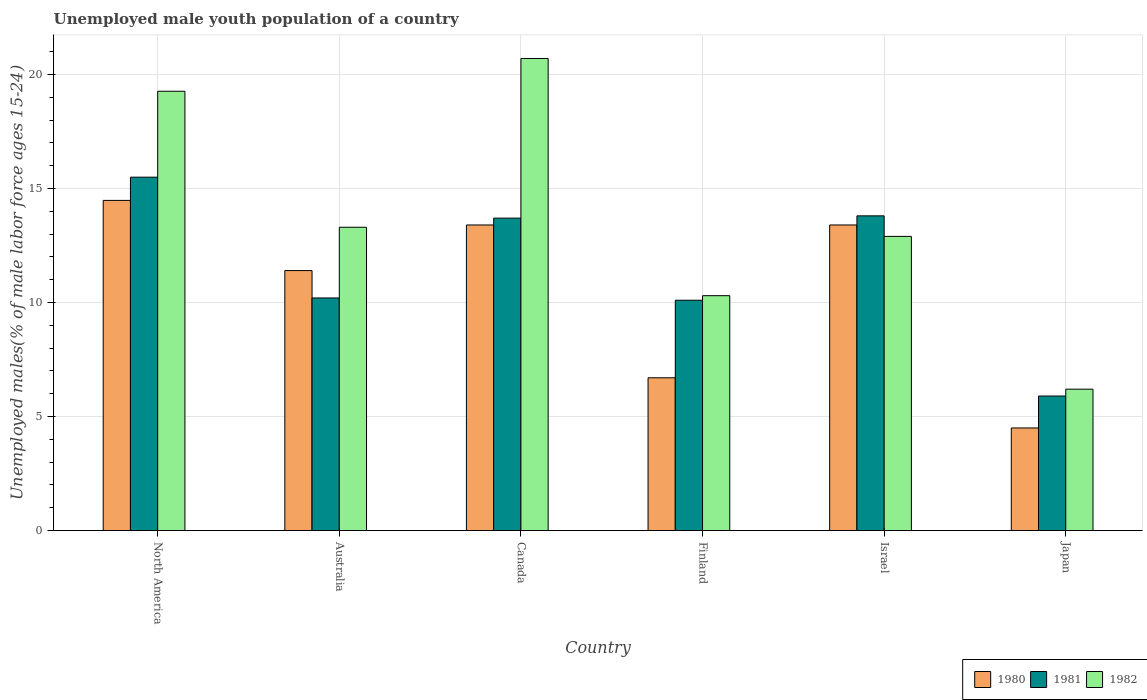How many groups of bars are there?
Offer a terse response. 6. Are the number of bars per tick equal to the number of legend labels?
Ensure brevity in your answer.  Yes. Are the number of bars on each tick of the X-axis equal?
Ensure brevity in your answer.  Yes. How many bars are there on the 1st tick from the left?
Your answer should be very brief. 3. How many bars are there on the 5th tick from the right?
Provide a succinct answer. 3. What is the label of the 4th group of bars from the left?
Give a very brief answer. Finland. In how many cases, is the number of bars for a given country not equal to the number of legend labels?
Provide a short and direct response. 0. What is the percentage of unemployed male youth population in 1982 in Israel?
Provide a short and direct response. 12.9. Across all countries, what is the maximum percentage of unemployed male youth population in 1982?
Ensure brevity in your answer.  20.7. Across all countries, what is the minimum percentage of unemployed male youth population in 1982?
Provide a short and direct response. 6.2. In which country was the percentage of unemployed male youth population in 1980 maximum?
Give a very brief answer. North America. What is the total percentage of unemployed male youth population in 1980 in the graph?
Provide a succinct answer. 63.88. What is the difference between the percentage of unemployed male youth population in 1982 in Finland and that in Israel?
Ensure brevity in your answer.  -2.6. What is the difference between the percentage of unemployed male youth population in 1981 in Israel and the percentage of unemployed male youth population in 1980 in Canada?
Provide a short and direct response. 0.4. What is the average percentage of unemployed male youth population in 1982 per country?
Keep it short and to the point. 13.78. What is the difference between the percentage of unemployed male youth population of/in 1980 and percentage of unemployed male youth population of/in 1981 in Australia?
Make the answer very short. 1.2. In how many countries, is the percentage of unemployed male youth population in 1980 greater than 1 %?
Offer a very short reply. 6. What is the ratio of the percentage of unemployed male youth population in 1980 in Australia to that in Finland?
Provide a succinct answer. 1.7. What is the difference between the highest and the second highest percentage of unemployed male youth population in 1981?
Your answer should be compact. -0.1. What is the difference between the highest and the lowest percentage of unemployed male youth population in 1982?
Ensure brevity in your answer.  14.5. Is the sum of the percentage of unemployed male youth population in 1982 in Australia and North America greater than the maximum percentage of unemployed male youth population in 1980 across all countries?
Your answer should be compact. Yes. What does the 3rd bar from the left in Finland represents?
Provide a succinct answer. 1982. What does the 1st bar from the right in North America represents?
Provide a succinct answer. 1982. Is it the case that in every country, the sum of the percentage of unemployed male youth population in 1980 and percentage of unemployed male youth population in 1981 is greater than the percentage of unemployed male youth population in 1982?
Your answer should be compact. Yes. Are all the bars in the graph horizontal?
Give a very brief answer. No. Does the graph contain grids?
Your answer should be very brief. Yes. Where does the legend appear in the graph?
Provide a succinct answer. Bottom right. How many legend labels are there?
Make the answer very short. 3. What is the title of the graph?
Make the answer very short. Unemployed male youth population of a country. Does "1985" appear as one of the legend labels in the graph?
Ensure brevity in your answer.  No. What is the label or title of the X-axis?
Offer a very short reply. Country. What is the label or title of the Y-axis?
Provide a short and direct response. Unemployed males(% of male labor force ages 15-24). What is the Unemployed males(% of male labor force ages 15-24) in 1980 in North America?
Keep it short and to the point. 14.48. What is the Unemployed males(% of male labor force ages 15-24) in 1981 in North America?
Provide a short and direct response. 15.5. What is the Unemployed males(% of male labor force ages 15-24) in 1982 in North America?
Keep it short and to the point. 19.26. What is the Unemployed males(% of male labor force ages 15-24) of 1980 in Australia?
Give a very brief answer. 11.4. What is the Unemployed males(% of male labor force ages 15-24) of 1981 in Australia?
Make the answer very short. 10.2. What is the Unemployed males(% of male labor force ages 15-24) of 1982 in Australia?
Offer a very short reply. 13.3. What is the Unemployed males(% of male labor force ages 15-24) of 1980 in Canada?
Give a very brief answer. 13.4. What is the Unemployed males(% of male labor force ages 15-24) in 1981 in Canada?
Provide a succinct answer. 13.7. What is the Unemployed males(% of male labor force ages 15-24) in 1982 in Canada?
Your answer should be very brief. 20.7. What is the Unemployed males(% of male labor force ages 15-24) in 1980 in Finland?
Your answer should be very brief. 6.7. What is the Unemployed males(% of male labor force ages 15-24) in 1981 in Finland?
Give a very brief answer. 10.1. What is the Unemployed males(% of male labor force ages 15-24) of 1982 in Finland?
Your answer should be very brief. 10.3. What is the Unemployed males(% of male labor force ages 15-24) in 1980 in Israel?
Provide a succinct answer. 13.4. What is the Unemployed males(% of male labor force ages 15-24) in 1981 in Israel?
Ensure brevity in your answer.  13.8. What is the Unemployed males(% of male labor force ages 15-24) in 1982 in Israel?
Your response must be concise. 12.9. What is the Unemployed males(% of male labor force ages 15-24) in 1980 in Japan?
Provide a short and direct response. 4.5. What is the Unemployed males(% of male labor force ages 15-24) in 1981 in Japan?
Ensure brevity in your answer.  5.9. What is the Unemployed males(% of male labor force ages 15-24) in 1982 in Japan?
Keep it short and to the point. 6.2. Across all countries, what is the maximum Unemployed males(% of male labor force ages 15-24) of 1980?
Offer a very short reply. 14.48. Across all countries, what is the maximum Unemployed males(% of male labor force ages 15-24) of 1981?
Make the answer very short. 15.5. Across all countries, what is the maximum Unemployed males(% of male labor force ages 15-24) of 1982?
Offer a very short reply. 20.7. Across all countries, what is the minimum Unemployed males(% of male labor force ages 15-24) of 1980?
Your answer should be very brief. 4.5. Across all countries, what is the minimum Unemployed males(% of male labor force ages 15-24) of 1981?
Give a very brief answer. 5.9. Across all countries, what is the minimum Unemployed males(% of male labor force ages 15-24) of 1982?
Give a very brief answer. 6.2. What is the total Unemployed males(% of male labor force ages 15-24) of 1980 in the graph?
Your response must be concise. 63.88. What is the total Unemployed males(% of male labor force ages 15-24) in 1981 in the graph?
Your response must be concise. 69.2. What is the total Unemployed males(% of male labor force ages 15-24) of 1982 in the graph?
Provide a short and direct response. 82.66. What is the difference between the Unemployed males(% of male labor force ages 15-24) in 1980 in North America and that in Australia?
Ensure brevity in your answer.  3.08. What is the difference between the Unemployed males(% of male labor force ages 15-24) of 1981 in North America and that in Australia?
Provide a succinct answer. 5.3. What is the difference between the Unemployed males(% of male labor force ages 15-24) in 1982 in North America and that in Australia?
Provide a succinct answer. 5.96. What is the difference between the Unemployed males(% of male labor force ages 15-24) in 1980 in North America and that in Canada?
Your response must be concise. 1.08. What is the difference between the Unemployed males(% of male labor force ages 15-24) in 1981 in North America and that in Canada?
Provide a succinct answer. 1.8. What is the difference between the Unemployed males(% of male labor force ages 15-24) in 1982 in North America and that in Canada?
Your response must be concise. -1.44. What is the difference between the Unemployed males(% of male labor force ages 15-24) in 1980 in North America and that in Finland?
Your answer should be compact. 7.78. What is the difference between the Unemployed males(% of male labor force ages 15-24) of 1981 in North America and that in Finland?
Ensure brevity in your answer.  5.4. What is the difference between the Unemployed males(% of male labor force ages 15-24) in 1982 in North America and that in Finland?
Your answer should be compact. 8.96. What is the difference between the Unemployed males(% of male labor force ages 15-24) in 1980 in North America and that in Israel?
Provide a short and direct response. 1.08. What is the difference between the Unemployed males(% of male labor force ages 15-24) of 1981 in North America and that in Israel?
Provide a succinct answer. 1.7. What is the difference between the Unemployed males(% of male labor force ages 15-24) of 1982 in North America and that in Israel?
Keep it short and to the point. 6.36. What is the difference between the Unemployed males(% of male labor force ages 15-24) of 1980 in North America and that in Japan?
Ensure brevity in your answer.  9.98. What is the difference between the Unemployed males(% of male labor force ages 15-24) in 1981 in North America and that in Japan?
Provide a short and direct response. 9.6. What is the difference between the Unemployed males(% of male labor force ages 15-24) of 1982 in North America and that in Japan?
Give a very brief answer. 13.06. What is the difference between the Unemployed males(% of male labor force ages 15-24) of 1980 in Australia and that in Canada?
Provide a succinct answer. -2. What is the difference between the Unemployed males(% of male labor force ages 15-24) in 1980 in Australia and that in Finland?
Offer a very short reply. 4.7. What is the difference between the Unemployed males(% of male labor force ages 15-24) in 1981 in Australia and that in Finland?
Provide a short and direct response. 0.1. What is the difference between the Unemployed males(% of male labor force ages 15-24) of 1982 in Australia and that in Finland?
Ensure brevity in your answer.  3. What is the difference between the Unemployed males(% of male labor force ages 15-24) in 1980 in Australia and that in Israel?
Offer a very short reply. -2. What is the difference between the Unemployed males(% of male labor force ages 15-24) of 1980 in Australia and that in Japan?
Provide a short and direct response. 6.9. What is the difference between the Unemployed males(% of male labor force ages 15-24) in 1980 in Canada and that in Finland?
Your answer should be compact. 6.7. What is the difference between the Unemployed males(% of male labor force ages 15-24) in 1982 in Canada and that in Finland?
Offer a very short reply. 10.4. What is the difference between the Unemployed males(% of male labor force ages 15-24) of 1980 in Canada and that in Israel?
Offer a very short reply. 0. What is the difference between the Unemployed males(% of male labor force ages 15-24) in 1981 in Canada and that in Israel?
Provide a short and direct response. -0.1. What is the difference between the Unemployed males(% of male labor force ages 15-24) in 1982 in Canada and that in Israel?
Provide a succinct answer. 7.8. What is the difference between the Unemployed males(% of male labor force ages 15-24) in 1981 in Canada and that in Japan?
Offer a terse response. 7.8. What is the difference between the Unemployed males(% of male labor force ages 15-24) in 1980 in Finland and that in Israel?
Ensure brevity in your answer.  -6.7. What is the difference between the Unemployed males(% of male labor force ages 15-24) of 1982 in Finland and that in Israel?
Offer a very short reply. -2.6. What is the difference between the Unemployed males(% of male labor force ages 15-24) of 1980 in Finland and that in Japan?
Your answer should be very brief. 2.2. What is the difference between the Unemployed males(% of male labor force ages 15-24) of 1982 in Finland and that in Japan?
Offer a terse response. 4.1. What is the difference between the Unemployed males(% of male labor force ages 15-24) in 1980 in Israel and that in Japan?
Give a very brief answer. 8.9. What is the difference between the Unemployed males(% of male labor force ages 15-24) in 1982 in Israel and that in Japan?
Your answer should be compact. 6.7. What is the difference between the Unemployed males(% of male labor force ages 15-24) in 1980 in North America and the Unemployed males(% of male labor force ages 15-24) in 1981 in Australia?
Offer a terse response. 4.28. What is the difference between the Unemployed males(% of male labor force ages 15-24) of 1980 in North America and the Unemployed males(% of male labor force ages 15-24) of 1982 in Australia?
Offer a terse response. 1.18. What is the difference between the Unemployed males(% of male labor force ages 15-24) in 1981 in North America and the Unemployed males(% of male labor force ages 15-24) in 1982 in Australia?
Make the answer very short. 2.2. What is the difference between the Unemployed males(% of male labor force ages 15-24) in 1980 in North America and the Unemployed males(% of male labor force ages 15-24) in 1981 in Canada?
Provide a short and direct response. 0.78. What is the difference between the Unemployed males(% of male labor force ages 15-24) in 1980 in North America and the Unemployed males(% of male labor force ages 15-24) in 1982 in Canada?
Give a very brief answer. -6.22. What is the difference between the Unemployed males(% of male labor force ages 15-24) of 1981 in North America and the Unemployed males(% of male labor force ages 15-24) of 1982 in Canada?
Offer a very short reply. -5.2. What is the difference between the Unemployed males(% of male labor force ages 15-24) of 1980 in North America and the Unemployed males(% of male labor force ages 15-24) of 1981 in Finland?
Provide a short and direct response. 4.38. What is the difference between the Unemployed males(% of male labor force ages 15-24) in 1980 in North America and the Unemployed males(% of male labor force ages 15-24) in 1982 in Finland?
Provide a succinct answer. 4.18. What is the difference between the Unemployed males(% of male labor force ages 15-24) in 1981 in North America and the Unemployed males(% of male labor force ages 15-24) in 1982 in Finland?
Keep it short and to the point. 5.2. What is the difference between the Unemployed males(% of male labor force ages 15-24) of 1980 in North America and the Unemployed males(% of male labor force ages 15-24) of 1981 in Israel?
Keep it short and to the point. 0.68. What is the difference between the Unemployed males(% of male labor force ages 15-24) of 1980 in North America and the Unemployed males(% of male labor force ages 15-24) of 1982 in Israel?
Your answer should be very brief. 1.58. What is the difference between the Unemployed males(% of male labor force ages 15-24) of 1981 in North America and the Unemployed males(% of male labor force ages 15-24) of 1982 in Israel?
Ensure brevity in your answer.  2.6. What is the difference between the Unemployed males(% of male labor force ages 15-24) of 1980 in North America and the Unemployed males(% of male labor force ages 15-24) of 1981 in Japan?
Keep it short and to the point. 8.58. What is the difference between the Unemployed males(% of male labor force ages 15-24) of 1980 in North America and the Unemployed males(% of male labor force ages 15-24) of 1982 in Japan?
Ensure brevity in your answer.  8.28. What is the difference between the Unemployed males(% of male labor force ages 15-24) of 1981 in North America and the Unemployed males(% of male labor force ages 15-24) of 1982 in Japan?
Your answer should be very brief. 9.3. What is the difference between the Unemployed males(% of male labor force ages 15-24) of 1980 in Australia and the Unemployed males(% of male labor force ages 15-24) of 1981 in Canada?
Ensure brevity in your answer.  -2.3. What is the difference between the Unemployed males(% of male labor force ages 15-24) of 1981 in Australia and the Unemployed males(% of male labor force ages 15-24) of 1982 in Canada?
Provide a short and direct response. -10.5. What is the difference between the Unemployed males(% of male labor force ages 15-24) of 1980 in Australia and the Unemployed males(% of male labor force ages 15-24) of 1982 in Finland?
Offer a terse response. 1.1. What is the difference between the Unemployed males(% of male labor force ages 15-24) of 1981 in Australia and the Unemployed males(% of male labor force ages 15-24) of 1982 in Finland?
Give a very brief answer. -0.1. What is the difference between the Unemployed males(% of male labor force ages 15-24) in 1980 in Australia and the Unemployed males(% of male labor force ages 15-24) in 1981 in Israel?
Your answer should be compact. -2.4. What is the difference between the Unemployed males(% of male labor force ages 15-24) of 1980 in Australia and the Unemployed males(% of male labor force ages 15-24) of 1982 in Israel?
Offer a terse response. -1.5. What is the difference between the Unemployed males(% of male labor force ages 15-24) in 1981 in Australia and the Unemployed males(% of male labor force ages 15-24) in 1982 in Israel?
Keep it short and to the point. -2.7. What is the difference between the Unemployed males(% of male labor force ages 15-24) of 1980 in Australia and the Unemployed males(% of male labor force ages 15-24) of 1981 in Japan?
Ensure brevity in your answer.  5.5. What is the difference between the Unemployed males(% of male labor force ages 15-24) in 1981 in Australia and the Unemployed males(% of male labor force ages 15-24) in 1982 in Japan?
Your response must be concise. 4. What is the difference between the Unemployed males(% of male labor force ages 15-24) in 1980 in Canada and the Unemployed males(% of male labor force ages 15-24) in 1982 in Finland?
Provide a short and direct response. 3.1. What is the difference between the Unemployed males(% of male labor force ages 15-24) of 1980 in Canada and the Unemployed males(% of male labor force ages 15-24) of 1982 in Israel?
Make the answer very short. 0.5. What is the difference between the Unemployed males(% of male labor force ages 15-24) in 1981 in Canada and the Unemployed males(% of male labor force ages 15-24) in 1982 in Israel?
Your response must be concise. 0.8. What is the difference between the Unemployed males(% of male labor force ages 15-24) in 1980 in Canada and the Unemployed males(% of male labor force ages 15-24) in 1981 in Japan?
Your answer should be compact. 7.5. What is the difference between the Unemployed males(% of male labor force ages 15-24) of 1981 in Canada and the Unemployed males(% of male labor force ages 15-24) of 1982 in Japan?
Your answer should be very brief. 7.5. What is the difference between the Unemployed males(% of male labor force ages 15-24) in 1980 in Finland and the Unemployed males(% of male labor force ages 15-24) in 1981 in Israel?
Your answer should be very brief. -7.1. What is the difference between the Unemployed males(% of male labor force ages 15-24) of 1981 in Finland and the Unemployed males(% of male labor force ages 15-24) of 1982 in Israel?
Ensure brevity in your answer.  -2.8. What is the difference between the Unemployed males(% of male labor force ages 15-24) of 1980 in Finland and the Unemployed males(% of male labor force ages 15-24) of 1982 in Japan?
Keep it short and to the point. 0.5. What is the difference between the Unemployed males(% of male labor force ages 15-24) of 1981 in Finland and the Unemployed males(% of male labor force ages 15-24) of 1982 in Japan?
Your response must be concise. 3.9. What is the difference between the Unemployed males(% of male labor force ages 15-24) in 1980 in Israel and the Unemployed males(% of male labor force ages 15-24) in 1982 in Japan?
Make the answer very short. 7.2. What is the average Unemployed males(% of male labor force ages 15-24) in 1980 per country?
Offer a very short reply. 10.65. What is the average Unemployed males(% of male labor force ages 15-24) in 1981 per country?
Offer a very short reply. 11.53. What is the average Unemployed males(% of male labor force ages 15-24) in 1982 per country?
Provide a succinct answer. 13.78. What is the difference between the Unemployed males(% of male labor force ages 15-24) of 1980 and Unemployed males(% of male labor force ages 15-24) of 1981 in North America?
Ensure brevity in your answer.  -1.02. What is the difference between the Unemployed males(% of male labor force ages 15-24) of 1980 and Unemployed males(% of male labor force ages 15-24) of 1982 in North America?
Provide a short and direct response. -4.79. What is the difference between the Unemployed males(% of male labor force ages 15-24) of 1981 and Unemployed males(% of male labor force ages 15-24) of 1982 in North America?
Provide a short and direct response. -3.77. What is the difference between the Unemployed males(% of male labor force ages 15-24) in 1980 and Unemployed males(% of male labor force ages 15-24) in 1981 in Australia?
Ensure brevity in your answer.  1.2. What is the difference between the Unemployed males(% of male labor force ages 15-24) in 1981 and Unemployed males(% of male labor force ages 15-24) in 1982 in Australia?
Provide a succinct answer. -3.1. What is the difference between the Unemployed males(% of male labor force ages 15-24) of 1980 and Unemployed males(% of male labor force ages 15-24) of 1981 in Canada?
Provide a short and direct response. -0.3. What is the difference between the Unemployed males(% of male labor force ages 15-24) in 1980 and Unemployed males(% of male labor force ages 15-24) in 1982 in Canada?
Offer a very short reply. -7.3. What is the difference between the Unemployed males(% of male labor force ages 15-24) of 1980 and Unemployed males(% of male labor force ages 15-24) of 1981 in Finland?
Your response must be concise. -3.4. What is the difference between the Unemployed males(% of male labor force ages 15-24) in 1981 and Unemployed males(% of male labor force ages 15-24) in 1982 in Finland?
Make the answer very short. -0.2. What is the difference between the Unemployed males(% of male labor force ages 15-24) in 1980 and Unemployed males(% of male labor force ages 15-24) in 1981 in Israel?
Provide a short and direct response. -0.4. What is the difference between the Unemployed males(% of male labor force ages 15-24) in 1980 and Unemployed males(% of male labor force ages 15-24) in 1981 in Japan?
Give a very brief answer. -1.4. What is the difference between the Unemployed males(% of male labor force ages 15-24) of 1981 and Unemployed males(% of male labor force ages 15-24) of 1982 in Japan?
Offer a terse response. -0.3. What is the ratio of the Unemployed males(% of male labor force ages 15-24) in 1980 in North America to that in Australia?
Offer a terse response. 1.27. What is the ratio of the Unemployed males(% of male labor force ages 15-24) of 1981 in North America to that in Australia?
Make the answer very short. 1.52. What is the ratio of the Unemployed males(% of male labor force ages 15-24) of 1982 in North America to that in Australia?
Provide a succinct answer. 1.45. What is the ratio of the Unemployed males(% of male labor force ages 15-24) of 1980 in North America to that in Canada?
Ensure brevity in your answer.  1.08. What is the ratio of the Unemployed males(% of male labor force ages 15-24) in 1981 in North America to that in Canada?
Make the answer very short. 1.13. What is the ratio of the Unemployed males(% of male labor force ages 15-24) of 1982 in North America to that in Canada?
Your response must be concise. 0.93. What is the ratio of the Unemployed males(% of male labor force ages 15-24) in 1980 in North America to that in Finland?
Your answer should be compact. 2.16. What is the ratio of the Unemployed males(% of male labor force ages 15-24) in 1981 in North America to that in Finland?
Keep it short and to the point. 1.53. What is the ratio of the Unemployed males(% of male labor force ages 15-24) of 1982 in North America to that in Finland?
Provide a short and direct response. 1.87. What is the ratio of the Unemployed males(% of male labor force ages 15-24) in 1980 in North America to that in Israel?
Provide a succinct answer. 1.08. What is the ratio of the Unemployed males(% of male labor force ages 15-24) of 1981 in North America to that in Israel?
Offer a terse response. 1.12. What is the ratio of the Unemployed males(% of male labor force ages 15-24) of 1982 in North America to that in Israel?
Your answer should be very brief. 1.49. What is the ratio of the Unemployed males(% of male labor force ages 15-24) in 1980 in North America to that in Japan?
Your answer should be compact. 3.22. What is the ratio of the Unemployed males(% of male labor force ages 15-24) of 1981 in North America to that in Japan?
Offer a terse response. 2.63. What is the ratio of the Unemployed males(% of male labor force ages 15-24) of 1982 in North America to that in Japan?
Your answer should be very brief. 3.11. What is the ratio of the Unemployed males(% of male labor force ages 15-24) in 1980 in Australia to that in Canada?
Your answer should be compact. 0.85. What is the ratio of the Unemployed males(% of male labor force ages 15-24) of 1981 in Australia to that in Canada?
Your response must be concise. 0.74. What is the ratio of the Unemployed males(% of male labor force ages 15-24) of 1982 in Australia to that in Canada?
Ensure brevity in your answer.  0.64. What is the ratio of the Unemployed males(% of male labor force ages 15-24) in 1980 in Australia to that in Finland?
Your response must be concise. 1.7. What is the ratio of the Unemployed males(% of male labor force ages 15-24) of 1981 in Australia to that in Finland?
Your answer should be very brief. 1.01. What is the ratio of the Unemployed males(% of male labor force ages 15-24) in 1982 in Australia to that in Finland?
Your answer should be compact. 1.29. What is the ratio of the Unemployed males(% of male labor force ages 15-24) of 1980 in Australia to that in Israel?
Offer a very short reply. 0.85. What is the ratio of the Unemployed males(% of male labor force ages 15-24) of 1981 in Australia to that in Israel?
Make the answer very short. 0.74. What is the ratio of the Unemployed males(% of male labor force ages 15-24) of 1982 in Australia to that in Israel?
Your response must be concise. 1.03. What is the ratio of the Unemployed males(% of male labor force ages 15-24) in 1980 in Australia to that in Japan?
Your response must be concise. 2.53. What is the ratio of the Unemployed males(% of male labor force ages 15-24) in 1981 in Australia to that in Japan?
Your response must be concise. 1.73. What is the ratio of the Unemployed males(% of male labor force ages 15-24) of 1982 in Australia to that in Japan?
Your answer should be very brief. 2.15. What is the ratio of the Unemployed males(% of male labor force ages 15-24) of 1981 in Canada to that in Finland?
Make the answer very short. 1.36. What is the ratio of the Unemployed males(% of male labor force ages 15-24) of 1982 in Canada to that in Finland?
Offer a very short reply. 2.01. What is the ratio of the Unemployed males(% of male labor force ages 15-24) in 1980 in Canada to that in Israel?
Offer a terse response. 1. What is the ratio of the Unemployed males(% of male labor force ages 15-24) in 1982 in Canada to that in Israel?
Offer a terse response. 1.6. What is the ratio of the Unemployed males(% of male labor force ages 15-24) of 1980 in Canada to that in Japan?
Make the answer very short. 2.98. What is the ratio of the Unemployed males(% of male labor force ages 15-24) of 1981 in Canada to that in Japan?
Your answer should be very brief. 2.32. What is the ratio of the Unemployed males(% of male labor force ages 15-24) in 1982 in Canada to that in Japan?
Provide a short and direct response. 3.34. What is the ratio of the Unemployed males(% of male labor force ages 15-24) of 1981 in Finland to that in Israel?
Your answer should be compact. 0.73. What is the ratio of the Unemployed males(% of male labor force ages 15-24) in 1982 in Finland to that in Israel?
Offer a very short reply. 0.8. What is the ratio of the Unemployed males(% of male labor force ages 15-24) of 1980 in Finland to that in Japan?
Give a very brief answer. 1.49. What is the ratio of the Unemployed males(% of male labor force ages 15-24) of 1981 in Finland to that in Japan?
Give a very brief answer. 1.71. What is the ratio of the Unemployed males(% of male labor force ages 15-24) of 1982 in Finland to that in Japan?
Provide a succinct answer. 1.66. What is the ratio of the Unemployed males(% of male labor force ages 15-24) of 1980 in Israel to that in Japan?
Give a very brief answer. 2.98. What is the ratio of the Unemployed males(% of male labor force ages 15-24) of 1981 in Israel to that in Japan?
Your answer should be compact. 2.34. What is the ratio of the Unemployed males(% of male labor force ages 15-24) in 1982 in Israel to that in Japan?
Make the answer very short. 2.08. What is the difference between the highest and the second highest Unemployed males(% of male labor force ages 15-24) in 1980?
Provide a succinct answer. 1.08. What is the difference between the highest and the second highest Unemployed males(% of male labor force ages 15-24) of 1981?
Your answer should be compact. 1.7. What is the difference between the highest and the second highest Unemployed males(% of male labor force ages 15-24) of 1982?
Make the answer very short. 1.44. What is the difference between the highest and the lowest Unemployed males(% of male labor force ages 15-24) of 1980?
Offer a very short reply. 9.98. What is the difference between the highest and the lowest Unemployed males(% of male labor force ages 15-24) of 1981?
Offer a terse response. 9.6. 